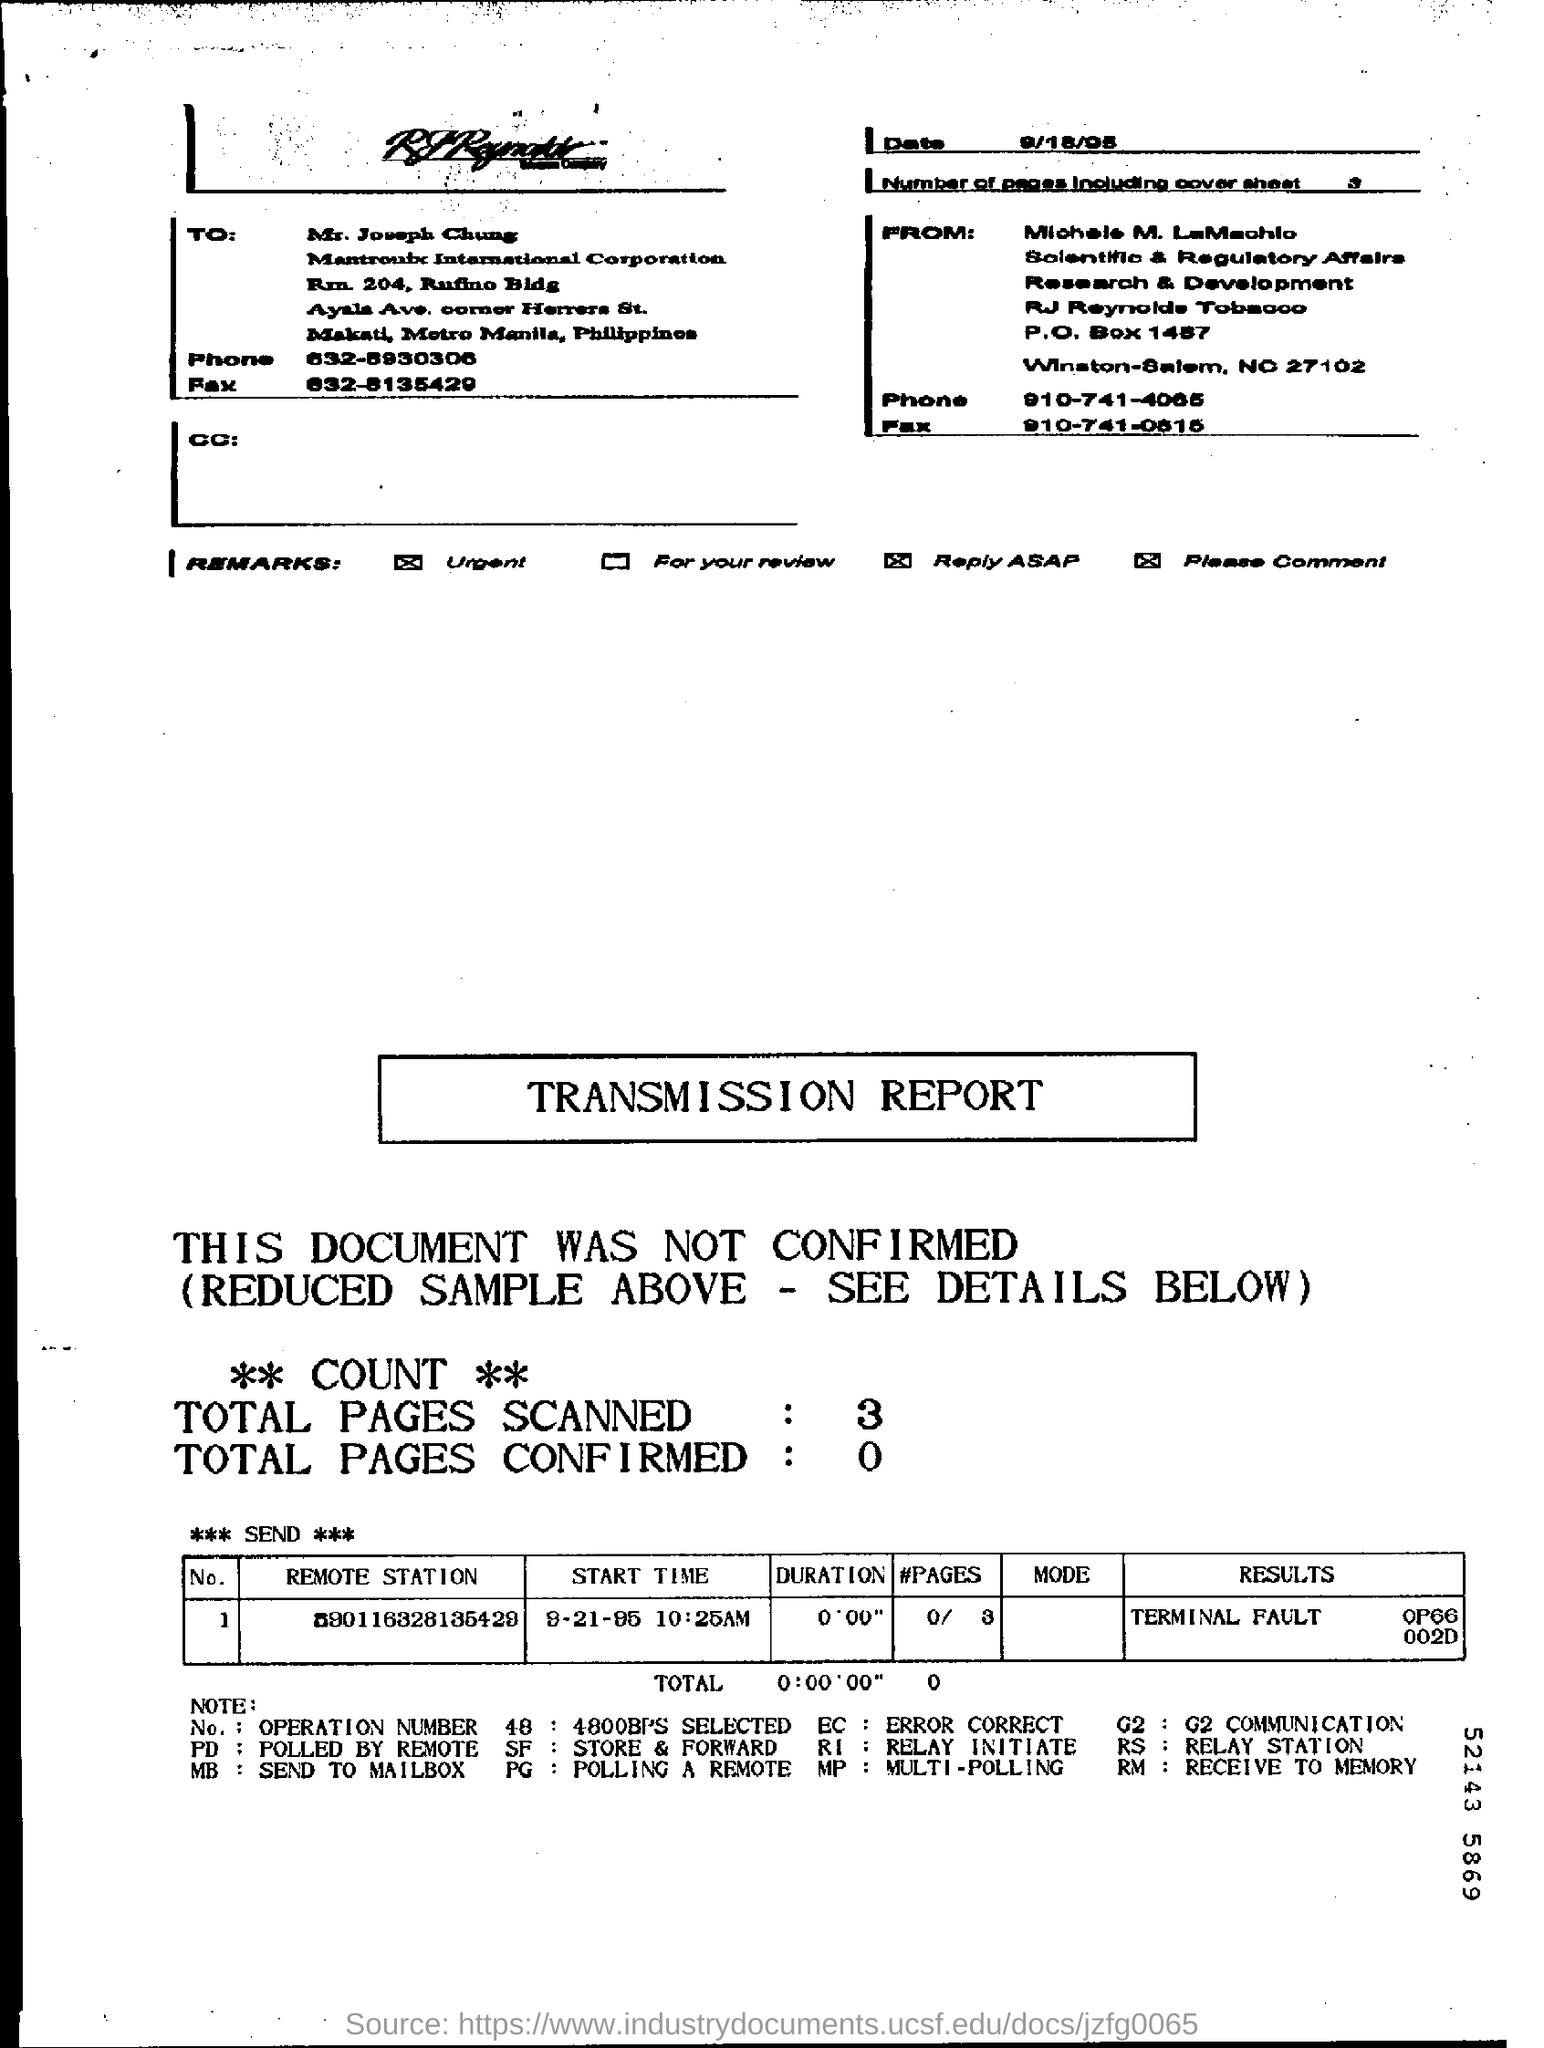Highlight a few significant elements in this photo. There are zero to one confirmed page. What is the Start Time? It is 9-21-95 at 10:25 AM. The total number of pages including the cover sheet is three. What is the "#Pages" in the table in the bottom referring to? The duration is a measurement of the amount of time that has elapsed or is scheduled to elapse, with a minimum value of 0 hours, 0 minutes, and 0 seconds, and a maximum value of an indefinite amount of time. 